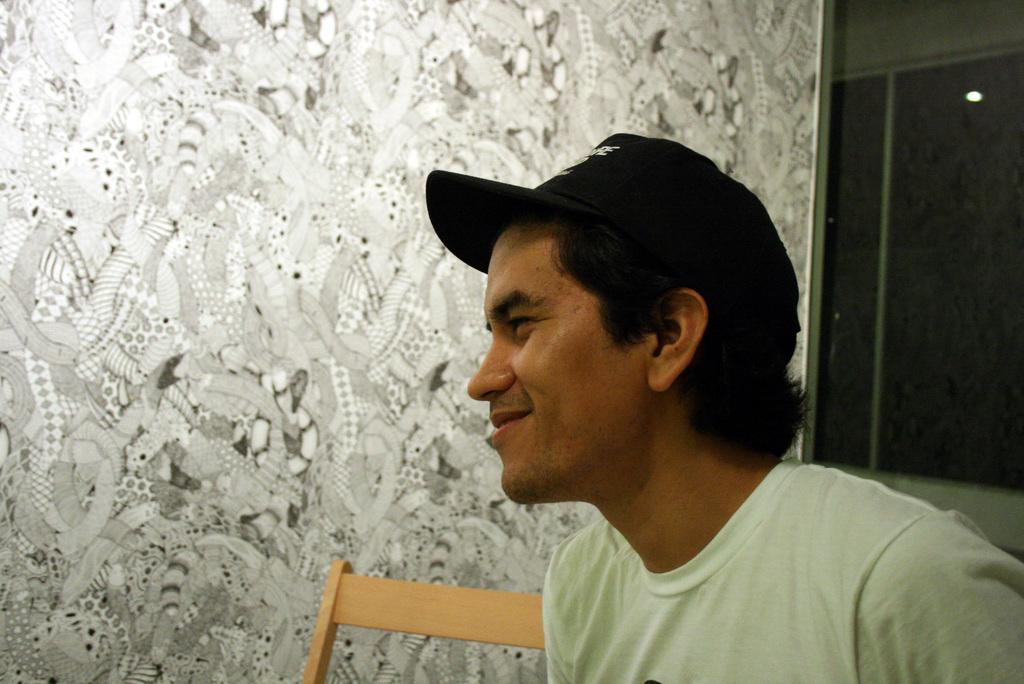What is the man in the image doing? The man is sitting at the bottom of the image. What is the man's facial expression in the image? The man is smiling in the image. What can be seen behind the man in the image? There is a wall behind the man in the image. What type of straw is the man holding in the image? There is no straw present in the image. What color is the sheet draped over the man in the image? There is no sheet present in the image. 